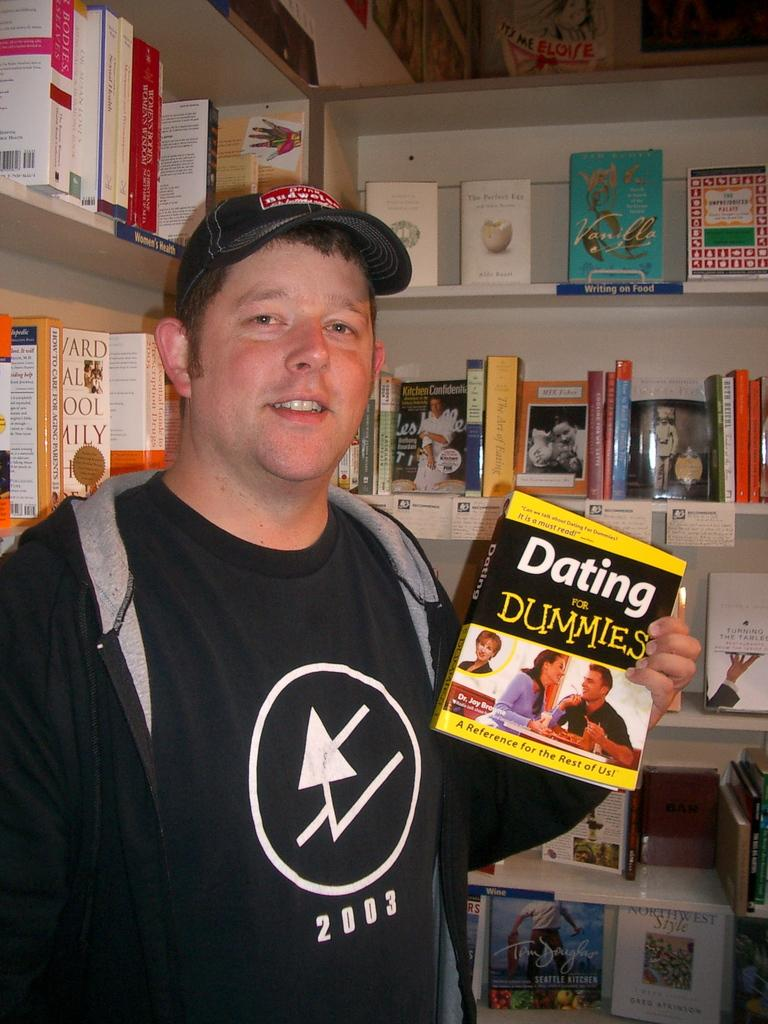<image>
Provide a brief description of the given image. A man in a black shirt holding up a dating for dummies book. 